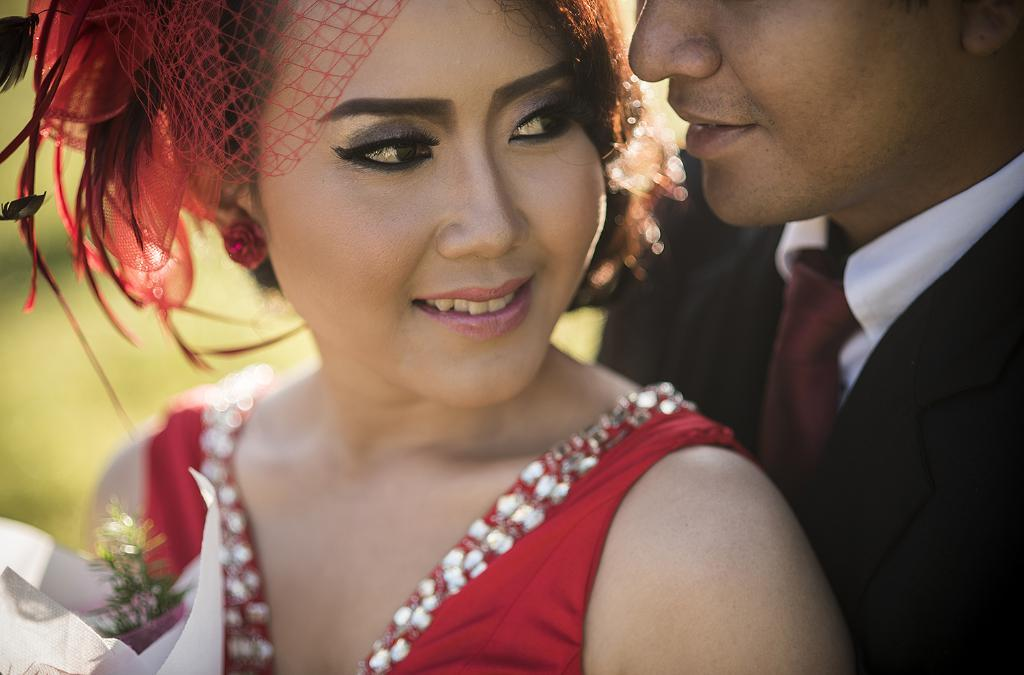Who is the main subject in the image? There is a girl in the image, and she is at the center of the image. What is the girl wearing? The girl is wearing a red dress. Are there any other people in the image? Yes, there is a man in the image. Where is the man located in the image? The man is on the right side of the image. What is the man wearing? The man is wearing a tie, shirt, and a coat. Can you see any cobwebs in the image? There is no mention of cobwebs in the image, so we cannot determine if they are present or not. 